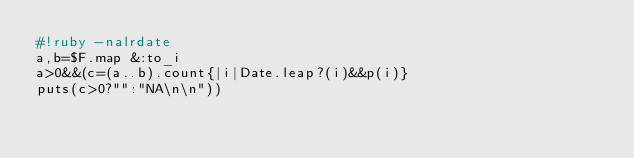<code> <loc_0><loc_0><loc_500><loc_500><_Ruby_>#!ruby -nalrdate
a,b=$F.map &:to_i
a>0&&(c=(a..b).count{|i|Date.leap?(i)&&p(i)}
puts(c>0?"":"NA\n\n"))</code> 